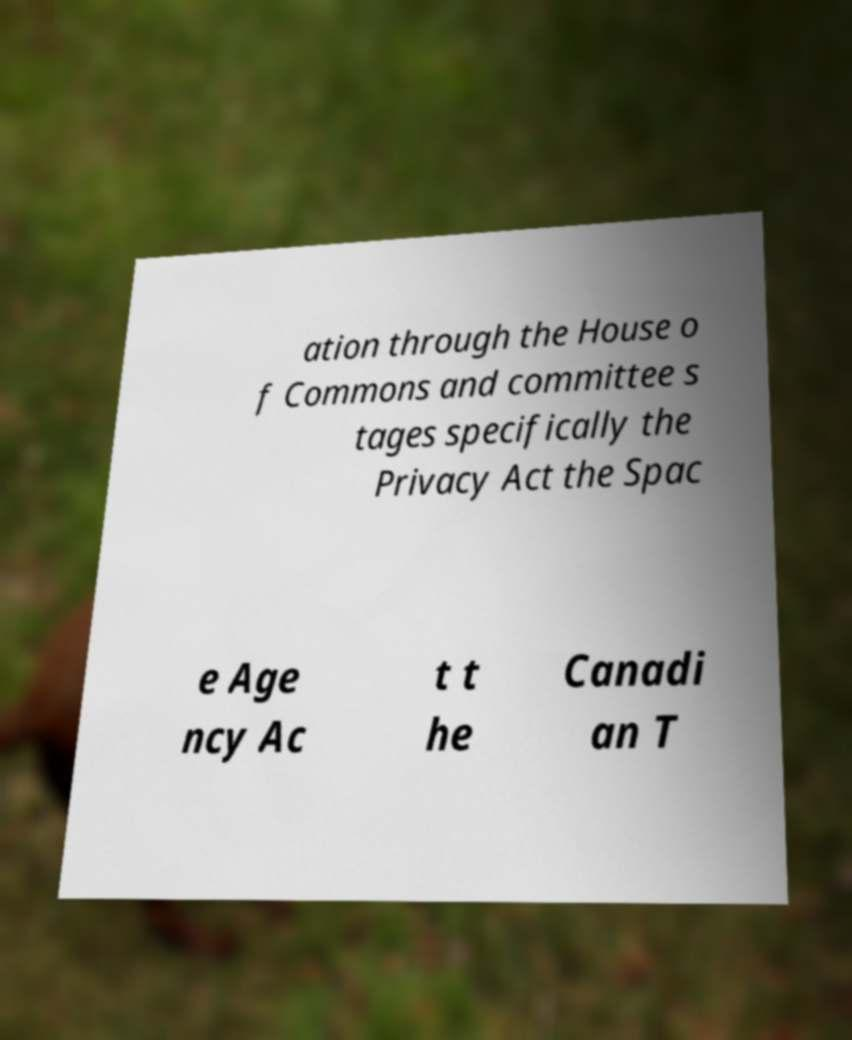There's text embedded in this image that I need extracted. Can you transcribe it verbatim? ation through the House o f Commons and committee s tages specifically the Privacy Act the Spac e Age ncy Ac t t he Canadi an T 